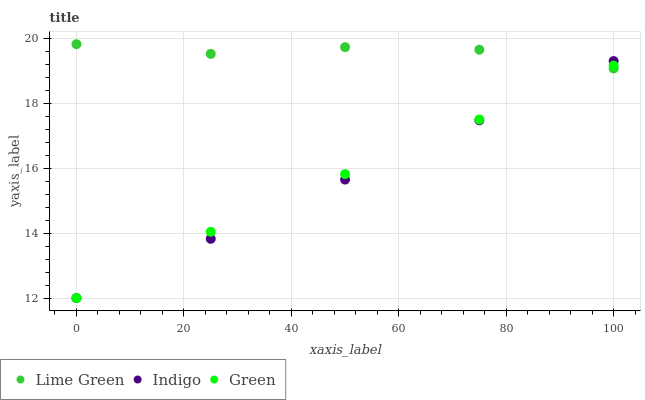Does Indigo have the minimum area under the curve?
Answer yes or no. Yes. Does Lime Green have the maximum area under the curve?
Answer yes or no. Yes. Does Green have the minimum area under the curve?
Answer yes or no. No. Does Green have the maximum area under the curve?
Answer yes or no. No. Is Indigo the smoothest?
Answer yes or no. Yes. Is Lime Green the roughest?
Answer yes or no. Yes. Is Green the smoothest?
Answer yes or no. No. Is Green the roughest?
Answer yes or no. No. Does Indigo have the lowest value?
Answer yes or no. Yes. Does Lime Green have the lowest value?
Answer yes or no. No. Does Lime Green have the highest value?
Answer yes or no. Yes. Does Green have the highest value?
Answer yes or no. No. Does Green intersect Lime Green?
Answer yes or no. Yes. Is Green less than Lime Green?
Answer yes or no. No. Is Green greater than Lime Green?
Answer yes or no. No. 